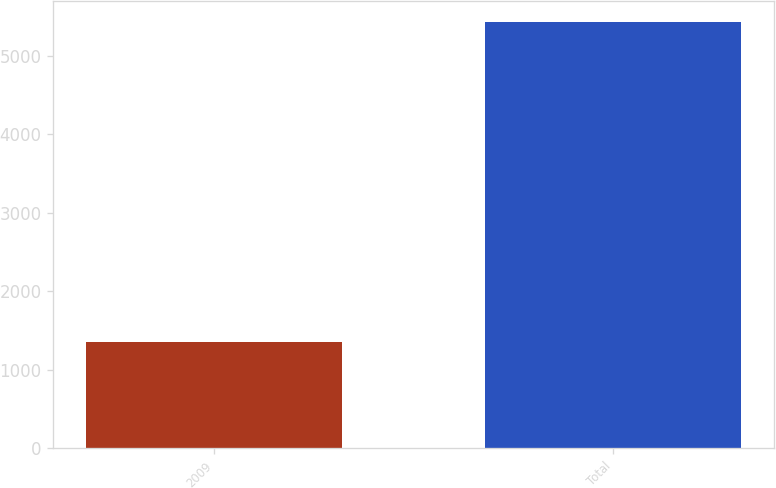<chart> <loc_0><loc_0><loc_500><loc_500><bar_chart><fcel>2009<fcel>Total<nl><fcel>1359<fcel>5427<nl></chart> 